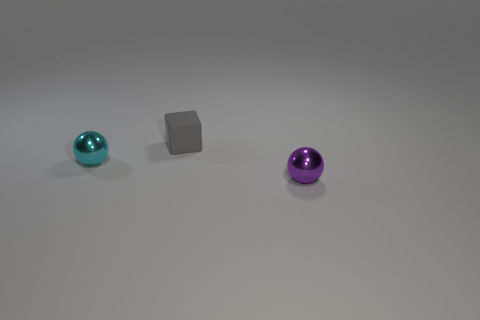Add 1 small balls. How many objects exist? 4 Subtract all spheres. How many objects are left? 1 Subtract 0 blue blocks. How many objects are left? 3 Subtract all green metallic blocks. Subtract all shiny objects. How many objects are left? 1 Add 2 small rubber blocks. How many small rubber blocks are left? 3 Add 1 purple things. How many purple things exist? 2 